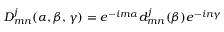<formula> <loc_0><loc_0><loc_500><loc_500>D _ { m n } ^ { j } ( \alpha , \beta , \gamma ) = e ^ { - i m \alpha } d _ { m n } ^ { j } ( \beta ) e ^ { - i n \gamma }</formula> 